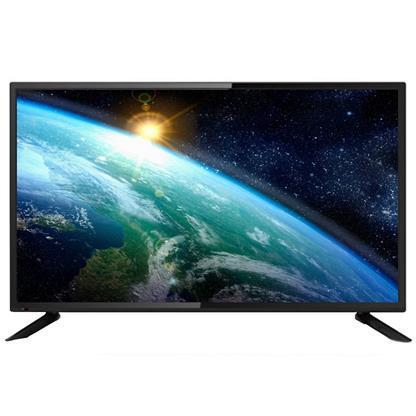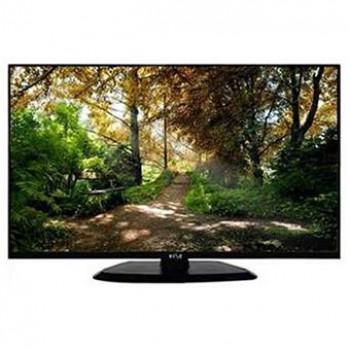The first image is the image on the left, the second image is the image on the right. Given the left and right images, does the statement "there is a sun glare in a monitor" hold true? Answer yes or no. Yes. The first image is the image on the left, the second image is the image on the right. For the images displayed, is the sentence "The television on the left has leg stands." factually correct? Answer yes or no. Yes. 